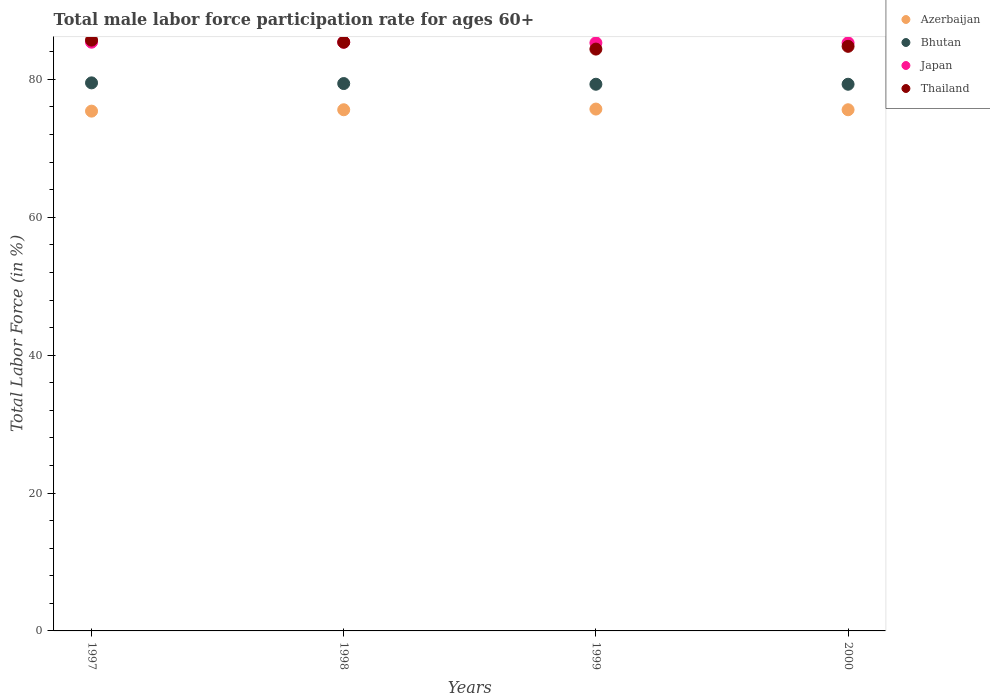What is the male labor force participation rate in Azerbaijan in 1998?
Ensure brevity in your answer.  75.6. Across all years, what is the maximum male labor force participation rate in Azerbaijan?
Your response must be concise. 75.7. Across all years, what is the minimum male labor force participation rate in Thailand?
Keep it short and to the point. 84.4. In which year was the male labor force participation rate in Japan minimum?
Provide a succinct answer. 1999. What is the total male labor force participation rate in Azerbaijan in the graph?
Offer a very short reply. 302.3. What is the difference between the male labor force participation rate in Thailand in 1998 and that in 2000?
Your response must be concise. 0.6. What is the difference between the male labor force participation rate in Japan in 1999 and the male labor force participation rate in Azerbaijan in 2000?
Keep it short and to the point. 9.7. What is the average male labor force participation rate in Bhutan per year?
Make the answer very short. 79.38. In how many years, is the male labor force participation rate in Thailand greater than 8 %?
Keep it short and to the point. 4. What is the ratio of the male labor force participation rate in Japan in 1997 to that in 1998?
Your answer should be compact. 1. Is the male labor force participation rate in Thailand in 1998 less than that in 2000?
Give a very brief answer. No. What is the difference between the highest and the lowest male labor force participation rate in Bhutan?
Ensure brevity in your answer.  0.2. How many dotlines are there?
Your answer should be very brief. 4. How many years are there in the graph?
Your response must be concise. 4. What is the difference between two consecutive major ticks on the Y-axis?
Your response must be concise. 20. Does the graph contain grids?
Your response must be concise. No. Where does the legend appear in the graph?
Offer a terse response. Top right. How many legend labels are there?
Offer a terse response. 4. How are the legend labels stacked?
Keep it short and to the point. Vertical. What is the title of the graph?
Your answer should be very brief. Total male labor force participation rate for ages 60+. What is the Total Labor Force (in %) of Azerbaijan in 1997?
Your answer should be compact. 75.4. What is the Total Labor Force (in %) in Bhutan in 1997?
Keep it short and to the point. 79.5. What is the Total Labor Force (in %) in Japan in 1997?
Keep it short and to the point. 85.4. What is the Total Labor Force (in %) of Thailand in 1997?
Your response must be concise. 85.7. What is the Total Labor Force (in %) in Azerbaijan in 1998?
Make the answer very short. 75.6. What is the Total Labor Force (in %) of Bhutan in 1998?
Give a very brief answer. 79.4. What is the Total Labor Force (in %) of Japan in 1998?
Your answer should be very brief. 85.4. What is the Total Labor Force (in %) of Thailand in 1998?
Keep it short and to the point. 85.4. What is the Total Labor Force (in %) of Azerbaijan in 1999?
Ensure brevity in your answer.  75.7. What is the Total Labor Force (in %) of Bhutan in 1999?
Keep it short and to the point. 79.3. What is the Total Labor Force (in %) in Japan in 1999?
Provide a short and direct response. 85.3. What is the Total Labor Force (in %) in Thailand in 1999?
Your answer should be compact. 84.4. What is the Total Labor Force (in %) of Azerbaijan in 2000?
Ensure brevity in your answer.  75.6. What is the Total Labor Force (in %) of Bhutan in 2000?
Provide a succinct answer. 79.3. What is the Total Labor Force (in %) in Japan in 2000?
Offer a very short reply. 85.3. What is the Total Labor Force (in %) in Thailand in 2000?
Offer a terse response. 84.8. Across all years, what is the maximum Total Labor Force (in %) of Azerbaijan?
Offer a very short reply. 75.7. Across all years, what is the maximum Total Labor Force (in %) in Bhutan?
Offer a terse response. 79.5. Across all years, what is the maximum Total Labor Force (in %) of Japan?
Your response must be concise. 85.4. Across all years, what is the maximum Total Labor Force (in %) in Thailand?
Offer a terse response. 85.7. Across all years, what is the minimum Total Labor Force (in %) of Azerbaijan?
Your answer should be very brief. 75.4. Across all years, what is the minimum Total Labor Force (in %) in Bhutan?
Ensure brevity in your answer.  79.3. Across all years, what is the minimum Total Labor Force (in %) of Japan?
Make the answer very short. 85.3. Across all years, what is the minimum Total Labor Force (in %) in Thailand?
Your response must be concise. 84.4. What is the total Total Labor Force (in %) of Azerbaijan in the graph?
Your response must be concise. 302.3. What is the total Total Labor Force (in %) in Bhutan in the graph?
Offer a terse response. 317.5. What is the total Total Labor Force (in %) of Japan in the graph?
Your answer should be compact. 341.4. What is the total Total Labor Force (in %) in Thailand in the graph?
Ensure brevity in your answer.  340.3. What is the difference between the Total Labor Force (in %) of Azerbaijan in 1997 and that in 1998?
Keep it short and to the point. -0.2. What is the difference between the Total Labor Force (in %) of Japan in 1997 and that in 1998?
Give a very brief answer. 0. What is the difference between the Total Labor Force (in %) in Thailand in 1997 and that in 1998?
Ensure brevity in your answer.  0.3. What is the difference between the Total Labor Force (in %) of Bhutan in 1997 and that in 1999?
Provide a succinct answer. 0.2. What is the difference between the Total Labor Force (in %) of Thailand in 1997 and that in 1999?
Provide a short and direct response. 1.3. What is the difference between the Total Labor Force (in %) of Japan in 1997 and that in 2000?
Provide a succinct answer. 0.1. What is the difference between the Total Labor Force (in %) in Azerbaijan in 1998 and that in 1999?
Your answer should be very brief. -0.1. What is the difference between the Total Labor Force (in %) in Bhutan in 1998 and that in 1999?
Ensure brevity in your answer.  0.1. What is the difference between the Total Labor Force (in %) in Japan in 1998 and that in 1999?
Ensure brevity in your answer.  0.1. What is the difference between the Total Labor Force (in %) in Thailand in 1998 and that in 1999?
Provide a succinct answer. 1. What is the difference between the Total Labor Force (in %) of Azerbaijan in 1998 and that in 2000?
Keep it short and to the point. 0. What is the difference between the Total Labor Force (in %) of Thailand in 1998 and that in 2000?
Make the answer very short. 0.6. What is the difference between the Total Labor Force (in %) of Azerbaijan in 1999 and that in 2000?
Keep it short and to the point. 0.1. What is the difference between the Total Labor Force (in %) in Bhutan in 1997 and the Total Labor Force (in %) in Japan in 1998?
Your answer should be very brief. -5.9. What is the difference between the Total Labor Force (in %) in Bhutan in 1997 and the Total Labor Force (in %) in Thailand in 1998?
Provide a succinct answer. -5.9. What is the difference between the Total Labor Force (in %) in Azerbaijan in 1997 and the Total Labor Force (in %) in Bhutan in 1999?
Offer a very short reply. -3.9. What is the difference between the Total Labor Force (in %) in Azerbaijan in 1997 and the Total Labor Force (in %) in Japan in 1999?
Give a very brief answer. -9.9. What is the difference between the Total Labor Force (in %) of Azerbaijan in 1997 and the Total Labor Force (in %) of Thailand in 1999?
Give a very brief answer. -9. What is the difference between the Total Labor Force (in %) of Bhutan in 1997 and the Total Labor Force (in %) of Japan in 1999?
Keep it short and to the point. -5.8. What is the difference between the Total Labor Force (in %) of Bhutan in 1997 and the Total Labor Force (in %) of Thailand in 1999?
Your answer should be very brief. -4.9. What is the difference between the Total Labor Force (in %) in Japan in 1997 and the Total Labor Force (in %) in Thailand in 1999?
Offer a very short reply. 1. What is the difference between the Total Labor Force (in %) in Azerbaijan in 1997 and the Total Labor Force (in %) in Bhutan in 2000?
Make the answer very short. -3.9. What is the difference between the Total Labor Force (in %) in Azerbaijan in 1997 and the Total Labor Force (in %) in Japan in 2000?
Make the answer very short. -9.9. What is the difference between the Total Labor Force (in %) in Bhutan in 1997 and the Total Labor Force (in %) in Thailand in 2000?
Give a very brief answer. -5.3. What is the difference between the Total Labor Force (in %) in Japan in 1997 and the Total Labor Force (in %) in Thailand in 2000?
Offer a very short reply. 0.6. What is the difference between the Total Labor Force (in %) of Azerbaijan in 1998 and the Total Labor Force (in %) of Japan in 1999?
Make the answer very short. -9.7. What is the difference between the Total Labor Force (in %) of Azerbaijan in 1998 and the Total Labor Force (in %) of Thailand in 1999?
Provide a succinct answer. -8.8. What is the difference between the Total Labor Force (in %) of Bhutan in 1998 and the Total Labor Force (in %) of Japan in 1999?
Your answer should be compact. -5.9. What is the difference between the Total Labor Force (in %) of Azerbaijan in 1998 and the Total Labor Force (in %) of Bhutan in 2000?
Give a very brief answer. -3.7. What is the difference between the Total Labor Force (in %) in Azerbaijan in 1998 and the Total Labor Force (in %) in Japan in 2000?
Offer a terse response. -9.7. What is the difference between the Total Labor Force (in %) of Bhutan in 1998 and the Total Labor Force (in %) of Japan in 2000?
Keep it short and to the point. -5.9. What is the difference between the Total Labor Force (in %) of Bhutan in 1998 and the Total Labor Force (in %) of Thailand in 2000?
Provide a succinct answer. -5.4. What is the difference between the Total Labor Force (in %) in Japan in 1998 and the Total Labor Force (in %) in Thailand in 2000?
Your response must be concise. 0.6. What is the difference between the Total Labor Force (in %) in Azerbaijan in 1999 and the Total Labor Force (in %) in Thailand in 2000?
Your answer should be compact. -9.1. What is the average Total Labor Force (in %) in Azerbaijan per year?
Offer a very short reply. 75.58. What is the average Total Labor Force (in %) of Bhutan per year?
Keep it short and to the point. 79.38. What is the average Total Labor Force (in %) of Japan per year?
Offer a very short reply. 85.35. What is the average Total Labor Force (in %) of Thailand per year?
Your response must be concise. 85.08. In the year 1997, what is the difference between the Total Labor Force (in %) in Azerbaijan and Total Labor Force (in %) in Bhutan?
Give a very brief answer. -4.1. In the year 1997, what is the difference between the Total Labor Force (in %) in Azerbaijan and Total Labor Force (in %) in Thailand?
Your answer should be compact. -10.3. In the year 1997, what is the difference between the Total Labor Force (in %) of Bhutan and Total Labor Force (in %) of Thailand?
Make the answer very short. -6.2. In the year 1998, what is the difference between the Total Labor Force (in %) of Azerbaijan and Total Labor Force (in %) of Bhutan?
Offer a very short reply. -3.8. In the year 1998, what is the difference between the Total Labor Force (in %) of Azerbaijan and Total Labor Force (in %) of Japan?
Your answer should be very brief. -9.8. In the year 1999, what is the difference between the Total Labor Force (in %) of Azerbaijan and Total Labor Force (in %) of Bhutan?
Your answer should be very brief. -3.6. In the year 1999, what is the difference between the Total Labor Force (in %) of Azerbaijan and Total Labor Force (in %) of Japan?
Offer a terse response. -9.6. In the year 1999, what is the difference between the Total Labor Force (in %) of Bhutan and Total Labor Force (in %) of Japan?
Offer a very short reply. -6. In the year 1999, what is the difference between the Total Labor Force (in %) of Bhutan and Total Labor Force (in %) of Thailand?
Ensure brevity in your answer.  -5.1. In the year 1999, what is the difference between the Total Labor Force (in %) in Japan and Total Labor Force (in %) in Thailand?
Your answer should be very brief. 0.9. In the year 2000, what is the difference between the Total Labor Force (in %) in Bhutan and Total Labor Force (in %) in Japan?
Ensure brevity in your answer.  -6. In the year 2000, what is the difference between the Total Labor Force (in %) of Japan and Total Labor Force (in %) of Thailand?
Your answer should be compact. 0.5. What is the ratio of the Total Labor Force (in %) of Azerbaijan in 1997 to that in 1999?
Offer a very short reply. 1. What is the ratio of the Total Labor Force (in %) of Thailand in 1997 to that in 1999?
Your answer should be very brief. 1.02. What is the ratio of the Total Labor Force (in %) of Azerbaijan in 1997 to that in 2000?
Ensure brevity in your answer.  1. What is the ratio of the Total Labor Force (in %) of Bhutan in 1997 to that in 2000?
Keep it short and to the point. 1. What is the ratio of the Total Labor Force (in %) in Japan in 1997 to that in 2000?
Your response must be concise. 1. What is the ratio of the Total Labor Force (in %) of Thailand in 1997 to that in 2000?
Ensure brevity in your answer.  1.01. What is the ratio of the Total Labor Force (in %) in Japan in 1998 to that in 1999?
Keep it short and to the point. 1. What is the ratio of the Total Labor Force (in %) in Thailand in 1998 to that in 1999?
Keep it short and to the point. 1.01. What is the ratio of the Total Labor Force (in %) in Azerbaijan in 1998 to that in 2000?
Your answer should be very brief. 1. What is the ratio of the Total Labor Force (in %) in Bhutan in 1998 to that in 2000?
Offer a terse response. 1. What is the ratio of the Total Labor Force (in %) in Japan in 1998 to that in 2000?
Provide a short and direct response. 1. What is the ratio of the Total Labor Force (in %) of Thailand in 1998 to that in 2000?
Keep it short and to the point. 1.01. What is the difference between the highest and the second highest Total Labor Force (in %) of Azerbaijan?
Provide a succinct answer. 0.1. What is the difference between the highest and the second highest Total Labor Force (in %) in Japan?
Your answer should be compact. 0. What is the difference between the highest and the second highest Total Labor Force (in %) in Thailand?
Offer a very short reply. 0.3. What is the difference between the highest and the lowest Total Labor Force (in %) of Japan?
Make the answer very short. 0.1. What is the difference between the highest and the lowest Total Labor Force (in %) of Thailand?
Make the answer very short. 1.3. 